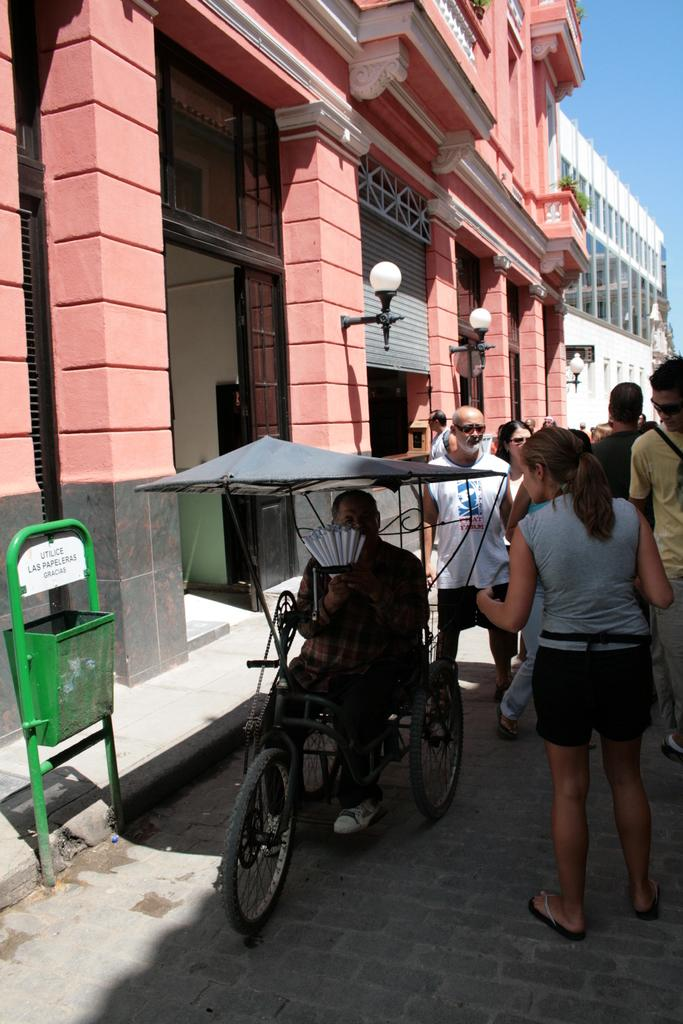What are the people in the image doing? The people in the image are standing on the road. Can you describe the man in the wheelchair? One man is sitting on a wheelchair in the image. What can be seen on the left side of the image? There are buildings on the left side of the image. Where is the girl with the heart-shaped balloon in the image? There is no girl or heart-shaped balloon present in the image. What type of nerve is visible in the image? There are no nerves visible in the image. 